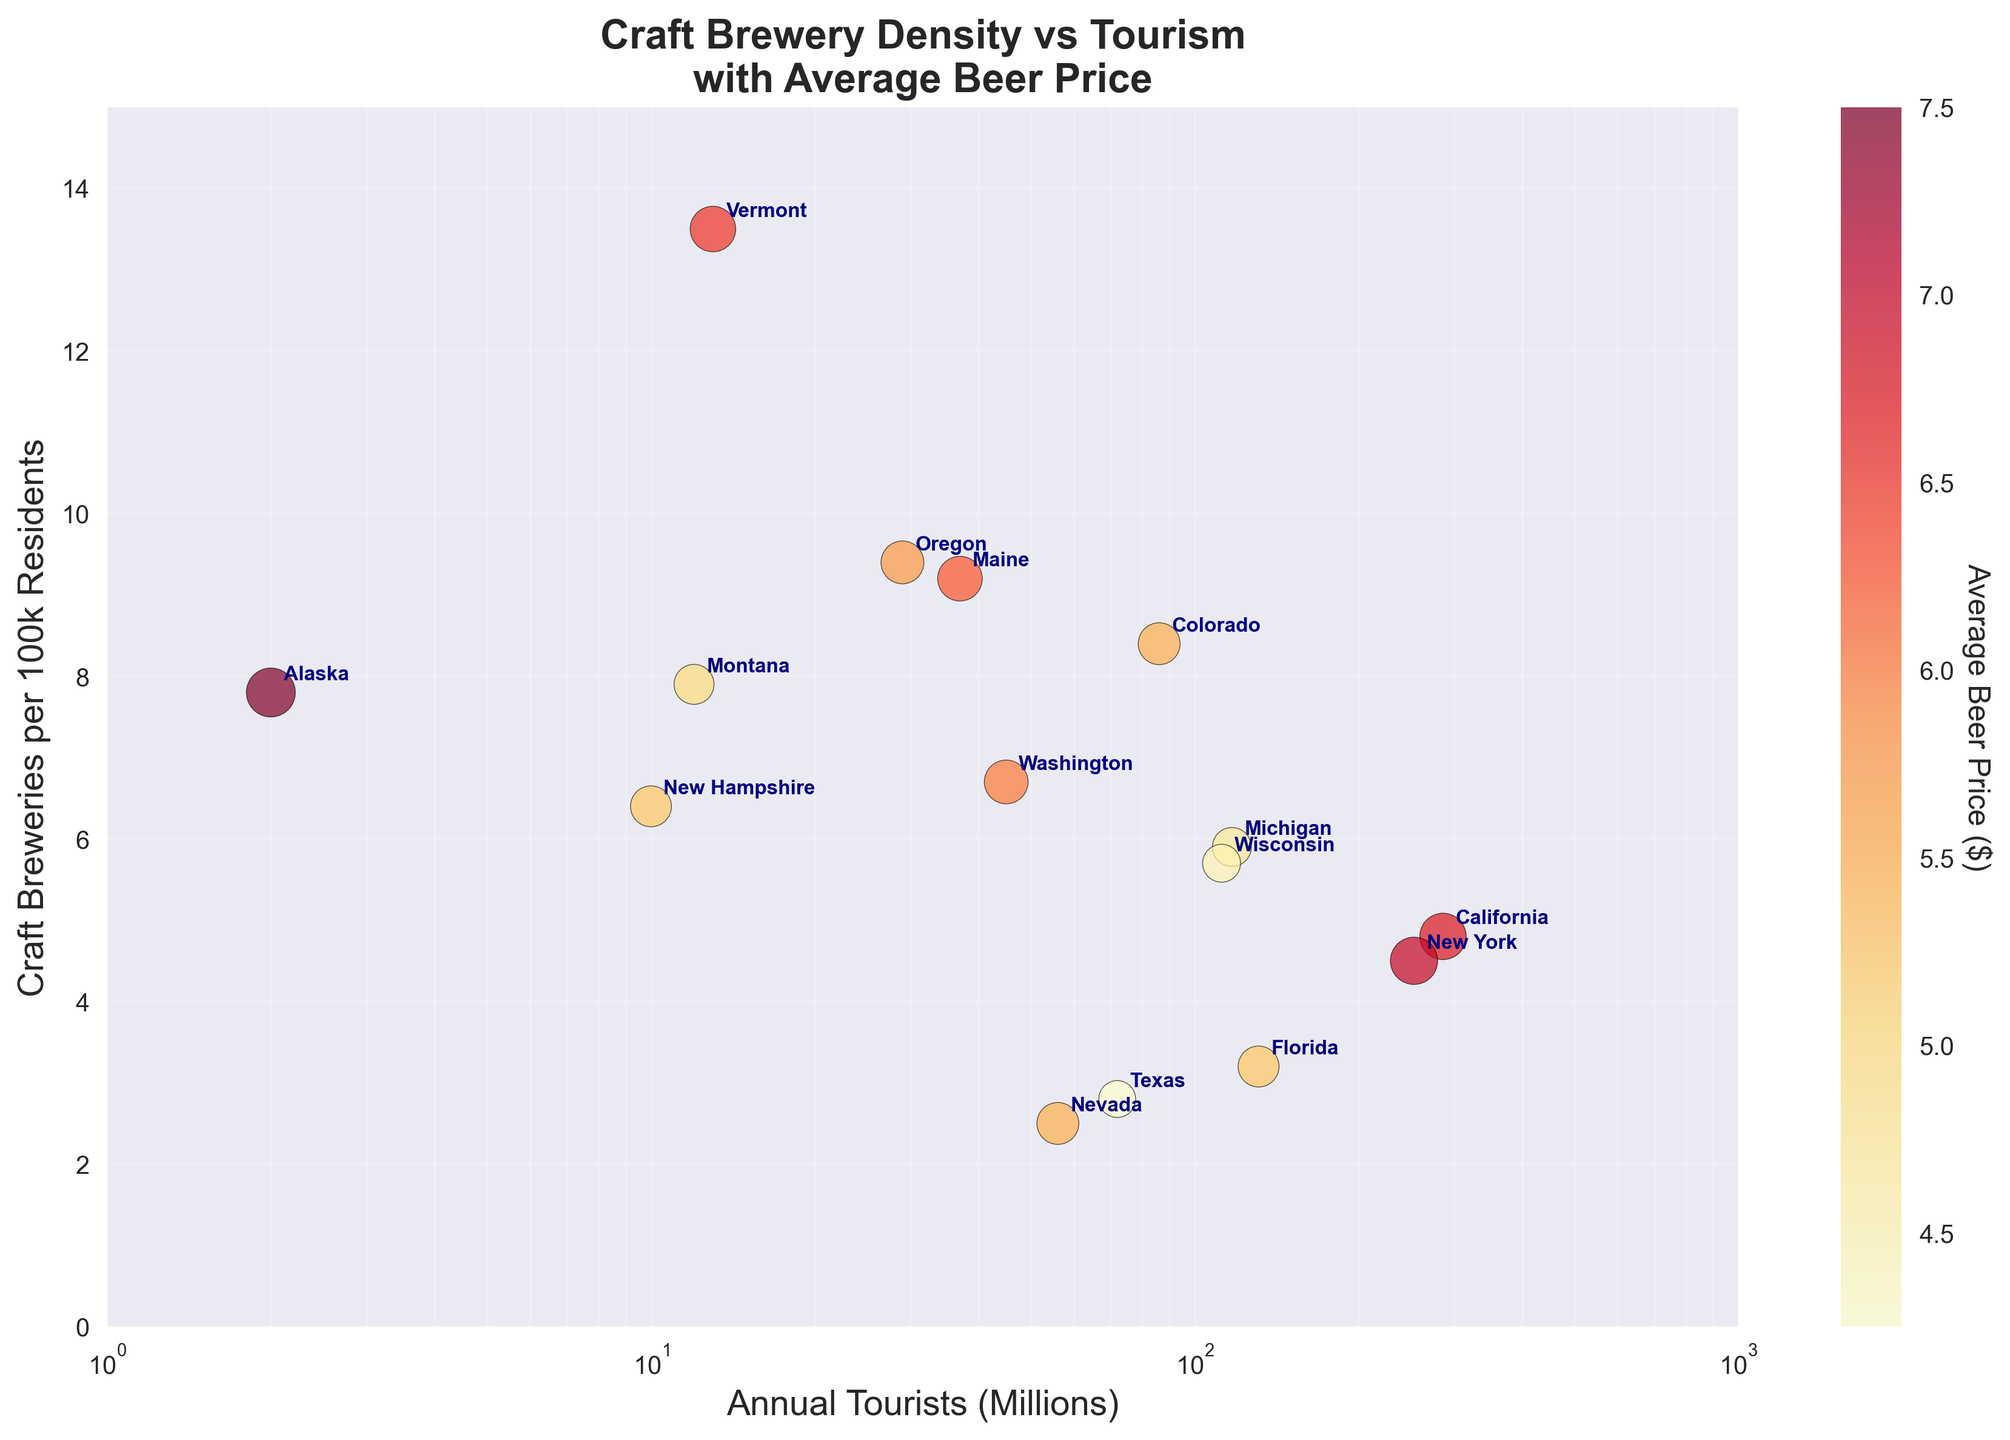What is the title of the plot? The title of the plot is displayed at the top in bold text.
Answer: Craft Brewery Density vs Tourism with Average Beer Price How is the x-axis scaled? The x-axis represents the number of annual tourists in millions and is scaled logarithmically, as indicated by the log scale notation and the spread of the ticks.
Answer: Logarithmically Which state has the highest number of craft breweries per 100k residents? By looking at the y-axis, Vermont has the highest value for craft breweries per 100k residents as its point is the highest on the vertical axis.
Answer: Vermont Which state has the highest average beer price? The color intensity represents the average beer price, and Alaska's point is the darkest, indicating the highest price.
Answer: Alaska What state's point lies closest to 100 million annual tourists? By examining the x-axis around the 100 million mark, Michigan is the state closest to this value.
Answer: Michigan Which state has both high craft brewery density and attracts a large number of tourists? Colorado stands out since it has a high position on the y-axis and is also far to the right on the x-axis, indicating high tourist numbers.
Answer: Colorado What is the correlation between craft brewery density and annual tourists? By observing the overall spread and trend of the data points, there doesn't seem to be a strong correlation; the points are quite scattered with no clear pattern.
Answer: Little or no correlation Among states with more than 100 million annual tourists, which has the lowest craft brewery density? For states beyond the 100 million annual tourists mark (New York, Florida, California, Michigan, Wisconsin), Florida has the lowest value on the y-axis.
Answer: Florida Is there any state that has a high number of annual tourists but a relatively low average beer price? Texas appears far to the right on the x-axis, indicating many tourists, and has a relatively lower coloration, suggesting a lower average beer price.
Answer: Texas Which states have a higher craft brewery density than Washington? From the plot, states positioned above Washington (on the y-axis) are Vermont, Oregon, Maine, Colorado, Montana, and Alaska.
Answer: Vermont, Oregon, Maine, Colorado, Montana, Alaska 